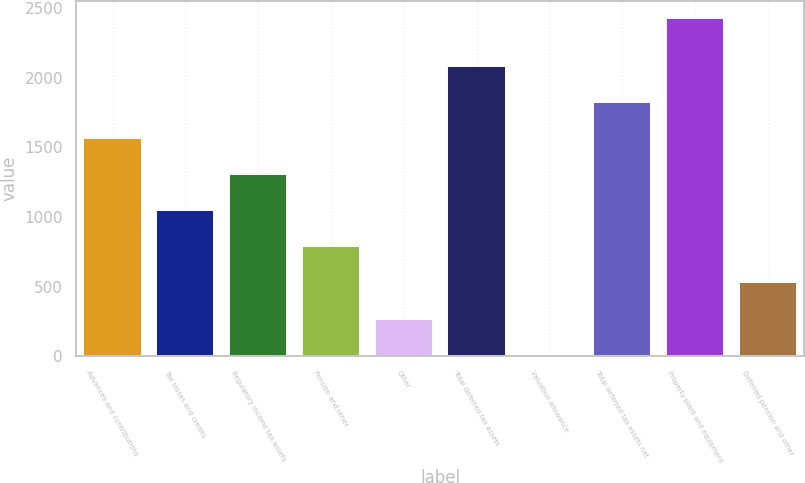<chart> <loc_0><loc_0><loc_500><loc_500><bar_chart><fcel>Advances and contributions<fcel>Tax losses and credits<fcel>Regulatory income tax assets<fcel>Pension and other<fcel>Other<fcel>Total deferred tax assets<fcel>Valuation allowance<fcel>Total deferred tax assets net<fcel>Property plant and equipment<fcel>Deferred pension and other<nl><fcel>1565.8<fcel>1048.2<fcel>1307<fcel>789.4<fcel>271.8<fcel>2083.4<fcel>13<fcel>1824.6<fcel>2429<fcel>530.6<nl></chart> 